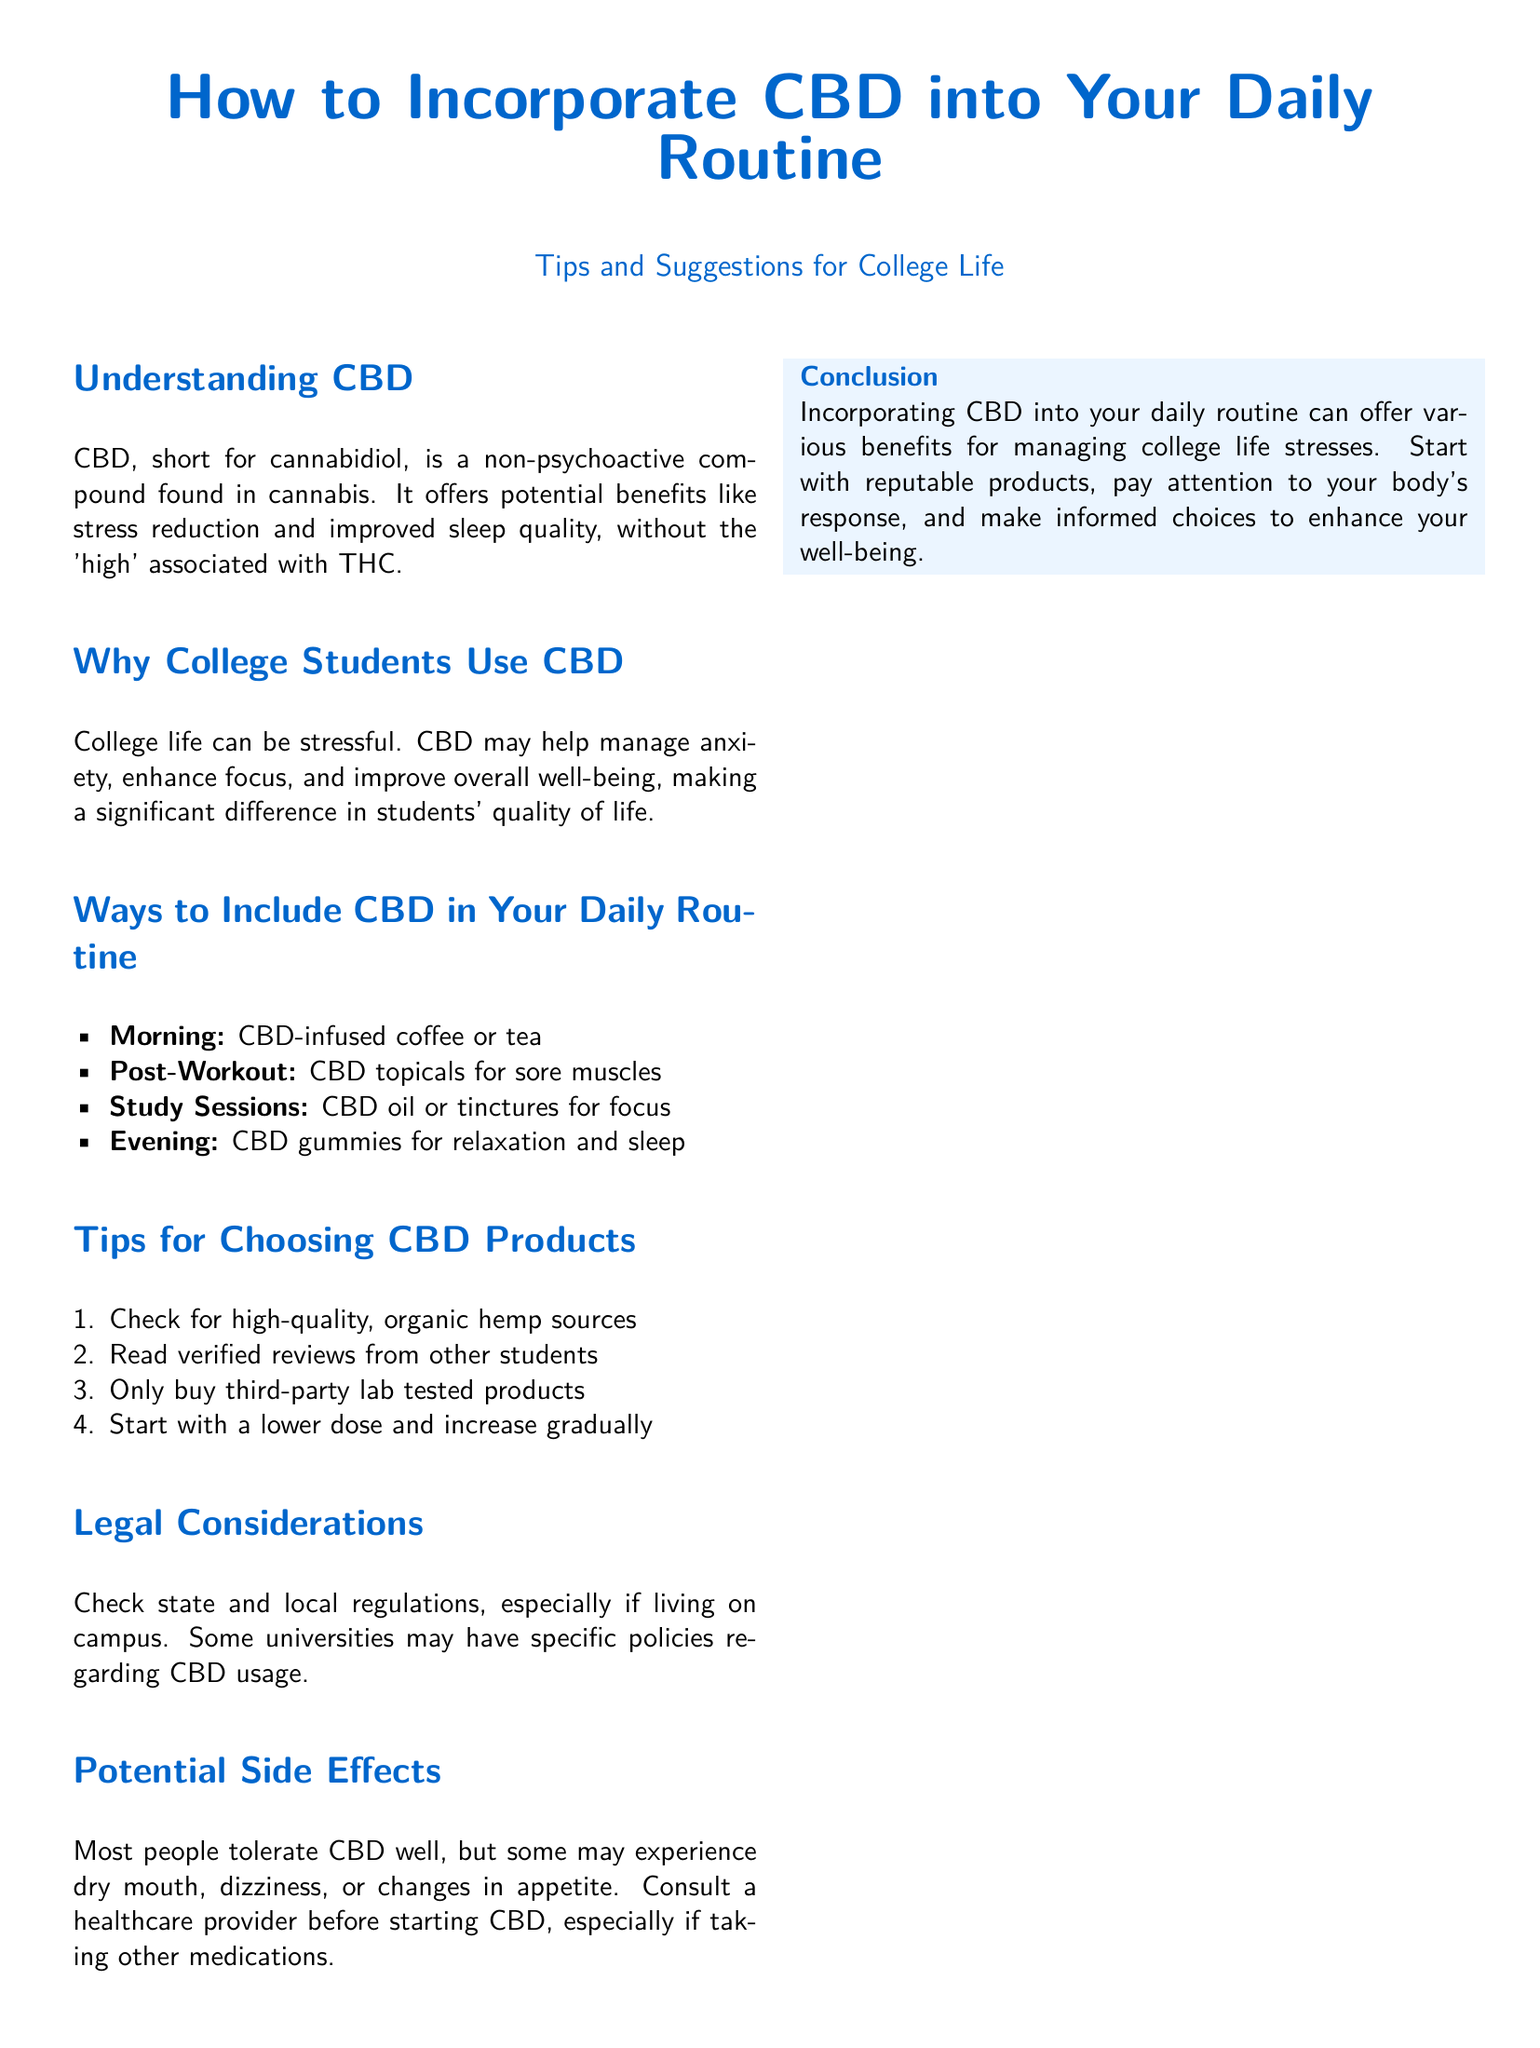What does CBD stand for? CBD stands for cannabidiol, as mentioned in the document.
Answer: cannabidiol What are the potential benefits of CBD mentioned? The document lists stress reduction and improved sleep quality as potential benefits.
Answer: stress reduction and improved sleep quality What time is suggested for taking CBD-infused coffee or tea? The document suggests using CBD-infused coffee or tea in the morning.
Answer: morning What type of CBD product is recommended for post-workout? CBD topicals are recommended for sore muscles after a workout.
Answer: CBD topicals What should you check for when choosing CBD products? The document advises checking for high-quality, organic hemp sources.
Answer: high-quality, organic hemp sources What should you do before starting CBD if you're on medication? The document suggests consulting a healthcare provider before starting CBD if taking other medications.
Answer: consult a healthcare provider How many tips for choosing CBD products are provided? The document includes four tips for choosing CBD products.
Answer: four What is the legal consideration regarding CBD mentioned? The document states to check state and local regulations regarding CBD usage.
Answer: check state and local regulations What are some potential side effects of CBD? The document mentions dry mouth, dizziness, or changes in appetite as potential side effects.
Answer: dry mouth, dizziness, or changes in appetite 